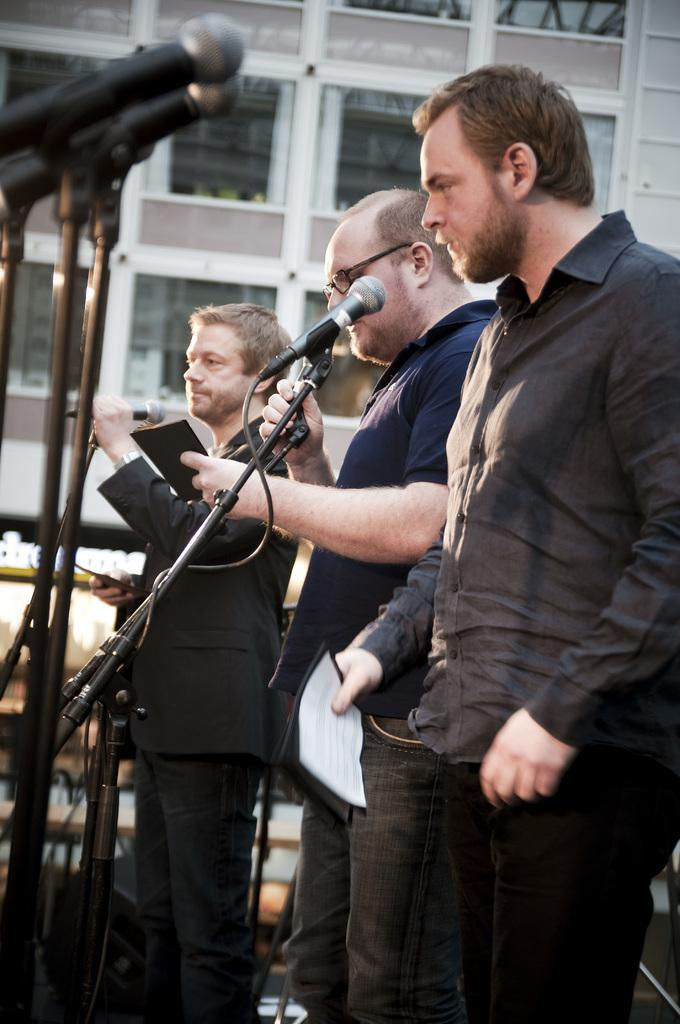How many people are in the image? There are three persons in the image. What are the persons doing in the image? The persons are standing in front of a microphone. What can be seen in the background of the image? There is a building in the background of the image. What type of ring is the person on the left wearing in the image? There is no ring visible on the person on the left in the image. 